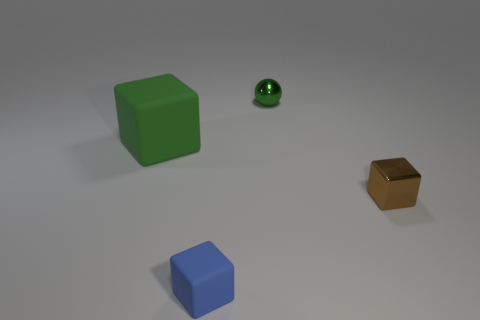What color is the object that is the same material as the brown cube?
Your response must be concise. Green. How many objects are tiny metal things behind the small brown cube or shiny blocks?
Your response must be concise. 2. What size is the metallic object in front of the small green sphere?
Offer a terse response. Small. There is a green rubber thing; is its size the same as the shiny thing that is behind the tiny brown thing?
Give a very brief answer. No. What color is the matte object that is on the left side of the matte block in front of the small brown block?
Offer a very short reply. Green. What number of other objects are there of the same color as the big cube?
Ensure brevity in your answer.  1. What is the size of the green shiny ball?
Offer a very short reply. Small. Is the number of metal spheres that are on the right side of the tiny metal block greater than the number of green blocks that are to the left of the green block?
Provide a short and direct response. No. There is a metal object in front of the green ball; what number of green objects are left of it?
Give a very brief answer. 2. Is the shape of the small thing on the right side of the shiny sphere the same as  the small green metal thing?
Offer a very short reply. No. 